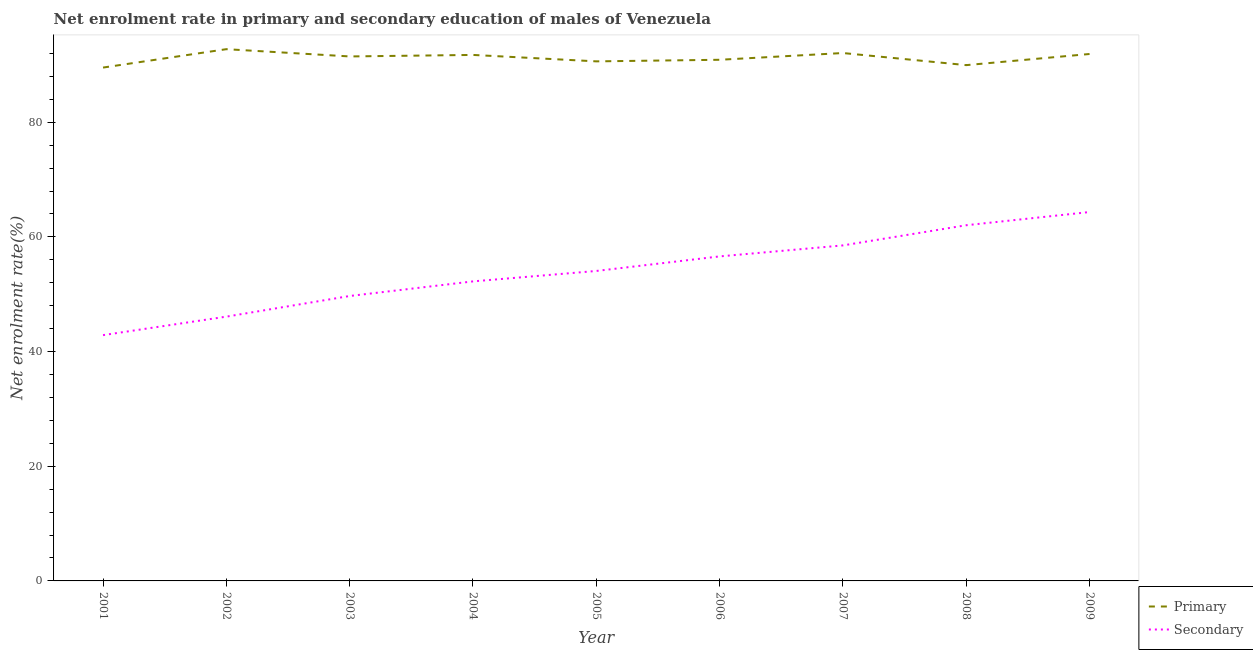How many different coloured lines are there?
Make the answer very short. 2. Is the number of lines equal to the number of legend labels?
Provide a succinct answer. Yes. What is the enrollment rate in primary education in 2006?
Your answer should be very brief. 90.89. Across all years, what is the maximum enrollment rate in primary education?
Offer a very short reply. 92.74. Across all years, what is the minimum enrollment rate in secondary education?
Ensure brevity in your answer.  42.87. In which year was the enrollment rate in secondary education minimum?
Make the answer very short. 2001. What is the total enrollment rate in secondary education in the graph?
Give a very brief answer. 486.46. What is the difference between the enrollment rate in secondary education in 2001 and that in 2002?
Offer a terse response. -3.22. What is the difference between the enrollment rate in primary education in 2007 and the enrollment rate in secondary education in 2003?
Offer a very short reply. 42.38. What is the average enrollment rate in primary education per year?
Ensure brevity in your answer.  91.22. In the year 2009, what is the difference between the enrollment rate in primary education and enrollment rate in secondary education?
Keep it short and to the point. 27.56. What is the ratio of the enrollment rate in primary education in 2004 to that in 2005?
Your answer should be very brief. 1.01. Is the enrollment rate in primary education in 2004 less than that in 2009?
Keep it short and to the point. Yes. What is the difference between the highest and the second highest enrollment rate in primary education?
Your response must be concise. 0.67. What is the difference between the highest and the lowest enrollment rate in secondary education?
Your response must be concise. 21.47. Is the sum of the enrollment rate in primary education in 2001 and 2006 greater than the maximum enrollment rate in secondary education across all years?
Provide a short and direct response. Yes. Is the enrollment rate in secondary education strictly greater than the enrollment rate in primary education over the years?
Ensure brevity in your answer.  No. How many years are there in the graph?
Ensure brevity in your answer.  9. Are the values on the major ticks of Y-axis written in scientific E-notation?
Offer a terse response. No. Does the graph contain any zero values?
Give a very brief answer. No. How many legend labels are there?
Make the answer very short. 2. What is the title of the graph?
Offer a very short reply. Net enrolment rate in primary and secondary education of males of Venezuela. Does "Automatic Teller Machines" appear as one of the legend labels in the graph?
Your response must be concise. No. What is the label or title of the Y-axis?
Offer a terse response. Net enrolment rate(%). What is the Net enrolment rate(%) in Primary in 2001?
Keep it short and to the point. 89.54. What is the Net enrolment rate(%) of Secondary in 2001?
Offer a terse response. 42.87. What is the Net enrolment rate(%) in Primary in 2002?
Provide a succinct answer. 92.74. What is the Net enrolment rate(%) in Secondary in 2002?
Give a very brief answer. 46.09. What is the Net enrolment rate(%) of Primary in 2003?
Offer a very short reply. 91.48. What is the Net enrolment rate(%) of Secondary in 2003?
Give a very brief answer. 49.69. What is the Net enrolment rate(%) of Primary in 2004?
Offer a very short reply. 91.74. What is the Net enrolment rate(%) of Secondary in 2004?
Ensure brevity in your answer.  52.24. What is the Net enrolment rate(%) of Primary in 2005?
Provide a short and direct response. 90.62. What is the Net enrolment rate(%) of Secondary in 2005?
Give a very brief answer. 54.06. What is the Net enrolment rate(%) in Primary in 2006?
Give a very brief answer. 90.89. What is the Net enrolment rate(%) of Secondary in 2006?
Keep it short and to the point. 56.6. What is the Net enrolment rate(%) of Primary in 2007?
Your response must be concise. 92.07. What is the Net enrolment rate(%) of Secondary in 2007?
Keep it short and to the point. 58.52. What is the Net enrolment rate(%) of Primary in 2008?
Keep it short and to the point. 89.96. What is the Net enrolment rate(%) of Secondary in 2008?
Give a very brief answer. 62.04. What is the Net enrolment rate(%) in Primary in 2009?
Your answer should be very brief. 91.9. What is the Net enrolment rate(%) in Secondary in 2009?
Your answer should be compact. 64.34. Across all years, what is the maximum Net enrolment rate(%) of Primary?
Your response must be concise. 92.74. Across all years, what is the maximum Net enrolment rate(%) in Secondary?
Offer a very short reply. 64.34. Across all years, what is the minimum Net enrolment rate(%) of Primary?
Offer a very short reply. 89.54. Across all years, what is the minimum Net enrolment rate(%) in Secondary?
Offer a terse response. 42.87. What is the total Net enrolment rate(%) in Primary in the graph?
Your response must be concise. 820.95. What is the total Net enrolment rate(%) in Secondary in the graph?
Keep it short and to the point. 486.46. What is the difference between the Net enrolment rate(%) of Primary in 2001 and that in 2002?
Your response must be concise. -3.21. What is the difference between the Net enrolment rate(%) of Secondary in 2001 and that in 2002?
Your response must be concise. -3.23. What is the difference between the Net enrolment rate(%) of Primary in 2001 and that in 2003?
Keep it short and to the point. -1.94. What is the difference between the Net enrolment rate(%) in Secondary in 2001 and that in 2003?
Your answer should be very brief. -6.82. What is the difference between the Net enrolment rate(%) in Primary in 2001 and that in 2004?
Offer a very short reply. -2.2. What is the difference between the Net enrolment rate(%) in Secondary in 2001 and that in 2004?
Give a very brief answer. -9.37. What is the difference between the Net enrolment rate(%) of Primary in 2001 and that in 2005?
Provide a succinct answer. -1.08. What is the difference between the Net enrolment rate(%) in Secondary in 2001 and that in 2005?
Your answer should be very brief. -11.19. What is the difference between the Net enrolment rate(%) of Primary in 2001 and that in 2006?
Your answer should be very brief. -1.36. What is the difference between the Net enrolment rate(%) in Secondary in 2001 and that in 2006?
Provide a succinct answer. -13.73. What is the difference between the Net enrolment rate(%) of Primary in 2001 and that in 2007?
Give a very brief answer. -2.54. What is the difference between the Net enrolment rate(%) in Secondary in 2001 and that in 2007?
Make the answer very short. -15.65. What is the difference between the Net enrolment rate(%) of Primary in 2001 and that in 2008?
Your answer should be compact. -0.42. What is the difference between the Net enrolment rate(%) in Secondary in 2001 and that in 2008?
Offer a terse response. -19.17. What is the difference between the Net enrolment rate(%) of Primary in 2001 and that in 2009?
Offer a very short reply. -2.37. What is the difference between the Net enrolment rate(%) of Secondary in 2001 and that in 2009?
Ensure brevity in your answer.  -21.47. What is the difference between the Net enrolment rate(%) of Primary in 2002 and that in 2003?
Ensure brevity in your answer.  1.27. What is the difference between the Net enrolment rate(%) of Secondary in 2002 and that in 2003?
Make the answer very short. -3.6. What is the difference between the Net enrolment rate(%) of Secondary in 2002 and that in 2004?
Provide a short and direct response. -6.15. What is the difference between the Net enrolment rate(%) in Primary in 2002 and that in 2005?
Your answer should be very brief. 2.13. What is the difference between the Net enrolment rate(%) of Secondary in 2002 and that in 2005?
Provide a short and direct response. -7.97. What is the difference between the Net enrolment rate(%) of Primary in 2002 and that in 2006?
Provide a short and direct response. 1.85. What is the difference between the Net enrolment rate(%) of Secondary in 2002 and that in 2006?
Your response must be concise. -10.51. What is the difference between the Net enrolment rate(%) of Primary in 2002 and that in 2007?
Give a very brief answer. 0.67. What is the difference between the Net enrolment rate(%) in Secondary in 2002 and that in 2007?
Offer a terse response. -12.42. What is the difference between the Net enrolment rate(%) in Primary in 2002 and that in 2008?
Your answer should be very brief. 2.78. What is the difference between the Net enrolment rate(%) in Secondary in 2002 and that in 2008?
Keep it short and to the point. -15.94. What is the difference between the Net enrolment rate(%) of Primary in 2002 and that in 2009?
Ensure brevity in your answer.  0.84. What is the difference between the Net enrolment rate(%) in Secondary in 2002 and that in 2009?
Offer a very short reply. -18.24. What is the difference between the Net enrolment rate(%) in Primary in 2003 and that in 2004?
Offer a terse response. -0.26. What is the difference between the Net enrolment rate(%) in Secondary in 2003 and that in 2004?
Offer a terse response. -2.55. What is the difference between the Net enrolment rate(%) in Primary in 2003 and that in 2005?
Make the answer very short. 0.86. What is the difference between the Net enrolment rate(%) of Secondary in 2003 and that in 2005?
Your answer should be compact. -4.37. What is the difference between the Net enrolment rate(%) in Primary in 2003 and that in 2006?
Keep it short and to the point. 0.58. What is the difference between the Net enrolment rate(%) of Secondary in 2003 and that in 2006?
Keep it short and to the point. -6.91. What is the difference between the Net enrolment rate(%) of Primary in 2003 and that in 2007?
Provide a succinct answer. -0.6. What is the difference between the Net enrolment rate(%) of Secondary in 2003 and that in 2007?
Your response must be concise. -8.82. What is the difference between the Net enrolment rate(%) in Primary in 2003 and that in 2008?
Your answer should be very brief. 1.52. What is the difference between the Net enrolment rate(%) of Secondary in 2003 and that in 2008?
Offer a terse response. -12.34. What is the difference between the Net enrolment rate(%) in Primary in 2003 and that in 2009?
Make the answer very short. -0.43. What is the difference between the Net enrolment rate(%) in Secondary in 2003 and that in 2009?
Offer a very short reply. -14.64. What is the difference between the Net enrolment rate(%) in Primary in 2004 and that in 2005?
Your answer should be compact. 1.12. What is the difference between the Net enrolment rate(%) in Secondary in 2004 and that in 2005?
Your answer should be compact. -1.82. What is the difference between the Net enrolment rate(%) of Primary in 2004 and that in 2006?
Ensure brevity in your answer.  0.85. What is the difference between the Net enrolment rate(%) in Secondary in 2004 and that in 2006?
Keep it short and to the point. -4.36. What is the difference between the Net enrolment rate(%) of Primary in 2004 and that in 2007?
Offer a terse response. -0.33. What is the difference between the Net enrolment rate(%) of Secondary in 2004 and that in 2007?
Your response must be concise. -6.28. What is the difference between the Net enrolment rate(%) in Primary in 2004 and that in 2008?
Give a very brief answer. 1.78. What is the difference between the Net enrolment rate(%) in Secondary in 2004 and that in 2008?
Offer a terse response. -9.79. What is the difference between the Net enrolment rate(%) in Primary in 2004 and that in 2009?
Ensure brevity in your answer.  -0.16. What is the difference between the Net enrolment rate(%) in Secondary in 2004 and that in 2009?
Give a very brief answer. -12.1. What is the difference between the Net enrolment rate(%) in Primary in 2005 and that in 2006?
Ensure brevity in your answer.  -0.28. What is the difference between the Net enrolment rate(%) in Secondary in 2005 and that in 2006?
Your response must be concise. -2.54. What is the difference between the Net enrolment rate(%) of Primary in 2005 and that in 2007?
Ensure brevity in your answer.  -1.45. What is the difference between the Net enrolment rate(%) of Secondary in 2005 and that in 2007?
Give a very brief answer. -4.46. What is the difference between the Net enrolment rate(%) in Primary in 2005 and that in 2008?
Offer a very short reply. 0.66. What is the difference between the Net enrolment rate(%) in Secondary in 2005 and that in 2008?
Offer a terse response. -7.98. What is the difference between the Net enrolment rate(%) of Primary in 2005 and that in 2009?
Offer a terse response. -1.28. What is the difference between the Net enrolment rate(%) of Secondary in 2005 and that in 2009?
Provide a succinct answer. -10.28. What is the difference between the Net enrolment rate(%) of Primary in 2006 and that in 2007?
Provide a succinct answer. -1.18. What is the difference between the Net enrolment rate(%) in Secondary in 2006 and that in 2007?
Offer a terse response. -1.92. What is the difference between the Net enrolment rate(%) of Primary in 2006 and that in 2008?
Your answer should be very brief. 0.93. What is the difference between the Net enrolment rate(%) of Secondary in 2006 and that in 2008?
Keep it short and to the point. -5.44. What is the difference between the Net enrolment rate(%) of Primary in 2006 and that in 2009?
Make the answer very short. -1.01. What is the difference between the Net enrolment rate(%) in Secondary in 2006 and that in 2009?
Your response must be concise. -7.74. What is the difference between the Net enrolment rate(%) in Primary in 2007 and that in 2008?
Make the answer very short. 2.11. What is the difference between the Net enrolment rate(%) of Secondary in 2007 and that in 2008?
Keep it short and to the point. -3.52. What is the difference between the Net enrolment rate(%) in Primary in 2007 and that in 2009?
Give a very brief answer. 0.17. What is the difference between the Net enrolment rate(%) of Secondary in 2007 and that in 2009?
Offer a very short reply. -5.82. What is the difference between the Net enrolment rate(%) of Primary in 2008 and that in 2009?
Keep it short and to the point. -1.94. What is the difference between the Net enrolment rate(%) in Secondary in 2008 and that in 2009?
Make the answer very short. -2.3. What is the difference between the Net enrolment rate(%) of Primary in 2001 and the Net enrolment rate(%) of Secondary in 2002?
Your answer should be compact. 43.44. What is the difference between the Net enrolment rate(%) of Primary in 2001 and the Net enrolment rate(%) of Secondary in 2003?
Ensure brevity in your answer.  39.84. What is the difference between the Net enrolment rate(%) of Primary in 2001 and the Net enrolment rate(%) of Secondary in 2004?
Keep it short and to the point. 37.29. What is the difference between the Net enrolment rate(%) of Primary in 2001 and the Net enrolment rate(%) of Secondary in 2005?
Your answer should be compact. 35.47. What is the difference between the Net enrolment rate(%) in Primary in 2001 and the Net enrolment rate(%) in Secondary in 2006?
Provide a short and direct response. 32.94. What is the difference between the Net enrolment rate(%) in Primary in 2001 and the Net enrolment rate(%) in Secondary in 2007?
Your answer should be compact. 31.02. What is the difference between the Net enrolment rate(%) in Primary in 2001 and the Net enrolment rate(%) in Secondary in 2008?
Make the answer very short. 27.5. What is the difference between the Net enrolment rate(%) of Primary in 2001 and the Net enrolment rate(%) of Secondary in 2009?
Offer a very short reply. 25.2. What is the difference between the Net enrolment rate(%) of Primary in 2002 and the Net enrolment rate(%) of Secondary in 2003?
Your response must be concise. 43.05. What is the difference between the Net enrolment rate(%) of Primary in 2002 and the Net enrolment rate(%) of Secondary in 2004?
Offer a very short reply. 40.5. What is the difference between the Net enrolment rate(%) of Primary in 2002 and the Net enrolment rate(%) of Secondary in 2005?
Ensure brevity in your answer.  38.68. What is the difference between the Net enrolment rate(%) of Primary in 2002 and the Net enrolment rate(%) of Secondary in 2006?
Offer a very short reply. 36.14. What is the difference between the Net enrolment rate(%) in Primary in 2002 and the Net enrolment rate(%) in Secondary in 2007?
Ensure brevity in your answer.  34.23. What is the difference between the Net enrolment rate(%) of Primary in 2002 and the Net enrolment rate(%) of Secondary in 2008?
Ensure brevity in your answer.  30.71. What is the difference between the Net enrolment rate(%) in Primary in 2002 and the Net enrolment rate(%) in Secondary in 2009?
Keep it short and to the point. 28.41. What is the difference between the Net enrolment rate(%) in Primary in 2003 and the Net enrolment rate(%) in Secondary in 2004?
Your answer should be very brief. 39.23. What is the difference between the Net enrolment rate(%) in Primary in 2003 and the Net enrolment rate(%) in Secondary in 2005?
Provide a short and direct response. 37.41. What is the difference between the Net enrolment rate(%) of Primary in 2003 and the Net enrolment rate(%) of Secondary in 2006?
Your response must be concise. 34.88. What is the difference between the Net enrolment rate(%) of Primary in 2003 and the Net enrolment rate(%) of Secondary in 2007?
Keep it short and to the point. 32.96. What is the difference between the Net enrolment rate(%) in Primary in 2003 and the Net enrolment rate(%) in Secondary in 2008?
Provide a short and direct response. 29.44. What is the difference between the Net enrolment rate(%) in Primary in 2003 and the Net enrolment rate(%) in Secondary in 2009?
Offer a very short reply. 27.14. What is the difference between the Net enrolment rate(%) of Primary in 2004 and the Net enrolment rate(%) of Secondary in 2005?
Make the answer very short. 37.68. What is the difference between the Net enrolment rate(%) in Primary in 2004 and the Net enrolment rate(%) in Secondary in 2006?
Give a very brief answer. 35.14. What is the difference between the Net enrolment rate(%) in Primary in 2004 and the Net enrolment rate(%) in Secondary in 2007?
Ensure brevity in your answer.  33.22. What is the difference between the Net enrolment rate(%) of Primary in 2004 and the Net enrolment rate(%) of Secondary in 2008?
Your response must be concise. 29.7. What is the difference between the Net enrolment rate(%) of Primary in 2004 and the Net enrolment rate(%) of Secondary in 2009?
Provide a succinct answer. 27.4. What is the difference between the Net enrolment rate(%) in Primary in 2005 and the Net enrolment rate(%) in Secondary in 2006?
Offer a terse response. 34.02. What is the difference between the Net enrolment rate(%) of Primary in 2005 and the Net enrolment rate(%) of Secondary in 2007?
Make the answer very short. 32.1. What is the difference between the Net enrolment rate(%) of Primary in 2005 and the Net enrolment rate(%) of Secondary in 2008?
Your answer should be very brief. 28.58. What is the difference between the Net enrolment rate(%) of Primary in 2005 and the Net enrolment rate(%) of Secondary in 2009?
Offer a terse response. 26.28. What is the difference between the Net enrolment rate(%) in Primary in 2006 and the Net enrolment rate(%) in Secondary in 2007?
Make the answer very short. 32.38. What is the difference between the Net enrolment rate(%) in Primary in 2006 and the Net enrolment rate(%) in Secondary in 2008?
Offer a terse response. 28.86. What is the difference between the Net enrolment rate(%) of Primary in 2006 and the Net enrolment rate(%) of Secondary in 2009?
Offer a terse response. 26.56. What is the difference between the Net enrolment rate(%) in Primary in 2007 and the Net enrolment rate(%) in Secondary in 2008?
Your answer should be compact. 30.03. What is the difference between the Net enrolment rate(%) in Primary in 2007 and the Net enrolment rate(%) in Secondary in 2009?
Your answer should be compact. 27.73. What is the difference between the Net enrolment rate(%) of Primary in 2008 and the Net enrolment rate(%) of Secondary in 2009?
Your answer should be compact. 25.62. What is the average Net enrolment rate(%) of Primary per year?
Give a very brief answer. 91.22. What is the average Net enrolment rate(%) of Secondary per year?
Give a very brief answer. 54.05. In the year 2001, what is the difference between the Net enrolment rate(%) of Primary and Net enrolment rate(%) of Secondary?
Make the answer very short. 46.67. In the year 2002, what is the difference between the Net enrolment rate(%) of Primary and Net enrolment rate(%) of Secondary?
Offer a very short reply. 46.65. In the year 2003, what is the difference between the Net enrolment rate(%) of Primary and Net enrolment rate(%) of Secondary?
Your answer should be very brief. 41.78. In the year 2004, what is the difference between the Net enrolment rate(%) in Primary and Net enrolment rate(%) in Secondary?
Provide a succinct answer. 39.5. In the year 2005, what is the difference between the Net enrolment rate(%) of Primary and Net enrolment rate(%) of Secondary?
Provide a succinct answer. 36.56. In the year 2006, what is the difference between the Net enrolment rate(%) of Primary and Net enrolment rate(%) of Secondary?
Ensure brevity in your answer.  34.29. In the year 2007, what is the difference between the Net enrolment rate(%) of Primary and Net enrolment rate(%) of Secondary?
Ensure brevity in your answer.  33.55. In the year 2008, what is the difference between the Net enrolment rate(%) in Primary and Net enrolment rate(%) in Secondary?
Your answer should be compact. 27.92. In the year 2009, what is the difference between the Net enrolment rate(%) in Primary and Net enrolment rate(%) in Secondary?
Give a very brief answer. 27.56. What is the ratio of the Net enrolment rate(%) in Primary in 2001 to that in 2002?
Provide a short and direct response. 0.97. What is the ratio of the Net enrolment rate(%) of Primary in 2001 to that in 2003?
Your answer should be very brief. 0.98. What is the ratio of the Net enrolment rate(%) in Secondary in 2001 to that in 2003?
Provide a short and direct response. 0.86. What is the ratio of the Net enrolment rate(%) in Primary in 2001 to that in 2004?
Provide a succinct answer. 0.98. What is the ratio of the Net enrolment rate(%) in Secondary in 2001 to that in 2004?
Your answer should be compact. 0.82. What is the ratio of the Net enrolment rate(%) of Secondary in 2001 to that in 2005?
Your answer should be compact. 0.79. What is the ratio of the Net enrolment rate(%) in Primary in 2001 to that in 2006?
Offer a very short reply. 0.99. What is the ratio of the Net enrolment rate(%) in Secondary in 2001 to that in 2006?
Your answer should be very brief. 0.76. What is the ratio of the Net enrolment rate(%) of Primary in 2001 to that in 2007?
Give a very brief answer. 0.97. What is the ratio of the Net enrolment rate(%) of Secondary in 2001 to that in 2007?
Give a very brief answer. 0.73. What is the ratio of the Net enrolment rate(%) of Secondary in 2001 to that in 2008?
Provide a short and direct response. 0.69. What is the ratio of the Net enrolment rate(%) of Primary in 2001 to that in 2009?
Give a very brief answer. 0.97. What is the ratio of the Net enrolment rate(%) of Secondary in 2001 to that in 2009?
Your response must be concise. 0.67. What is the ratio of the Net enrolment rate(%) of Primary in 2002 to that in 2003?
Your answer should be compact. 1.01. What is the ratio of the Net enrolment rate(%) in Secondary in 2002 to that in 2003?
Offer a very short reply. 0.93. What is the ratio of the Net enrolment rate(%) of Primary in 2002 to that in 2004?
Make the answer very short. 1.01. What is the ratio of the Net enrolment rate(%) of Secondary in 2002 to that in 2004?
Provide a short and direct response. 0.88. What is the ratio of the Net enrolment rate(%) in Primary in 2002 to that in 2005?
Offer a terse response. 1.02. What is the ratio of the Net enrolment rate(%) in Secondary in 2002 to that in 2005?
Provide a short and direct response. 0.85. What is the ratio of the Net enrolment rate(%) of Primary in 2002 to that in 2006?
Offer a terse response. 1.02. What is the ratio of the Net enrolment rate(%) of Secondary in 2002 to that in 2006?
Offer a terse response. 0.81. What is the ratio of the Net enrolment rate(%) in Primary in 2002 to that in 2007?
Your response must be concise. 1.01. What is the ratio of the Net enrolment rate(%) in Secondary in 2002 to that in 2007?
Keep it short and to the point. 0.79. What is the ratio of the Net enrolment rate(%) of Primary in 2002 to that in 2008?
Make the answer very short. 1.03. What is the ratio of the Net enrolment rate(%) in Secondary in 2002 to that in 2008?
Your answer should be very brief. 0.74. What is the ratio of the Net enrolment rate(%) in Primary in 2002 to that in 2009?
Provide a short and direct response. 1.01. What is the ratio of the Net enrolment rate(%) in Secondary in 2002 to that in 2009?
Provide a succinct answer. 0.72. What is the ratio of the Net enrolment rate(%) in Secondary in 2003 to that in 2004?
Give a very brief answer. 0.95. What is the ratio of the Net enrolment rate(%) of Primary in 2003 to that in 2005?
Your answer should be very brief. 1.01. What is the ratio of the Net enrolment rate(%) in Secondary in 2003 to that in 2005?
Your answer should be compact. 0.92. What is the ratio of the Net enrolment rate(%) in Primary in 2003 to that in 2006?
Your answer should be very brief. 1.01. What is the ratio of the Net enrolment rate(%) in Secondary in 2003 to that in 2006?
Your response must be concise. 0.88. What is the ratio of the Net enrolment rate(%) of Primary in 2003 to that in 2007?
Provide a short and direct response. 0.99. What is the ratio of the Net enrolment rate(%) in Secondary in 2003 to that in 2007?
Offer a very short reply. 0.85. What is the ratio of the Net enrolment rate(%) of Primary in 2003 to that in 2008?
Your response must be concise. 1.02. What is the ratio of the Net enrolment rate(%) in Secondary in 2003 to that in 2008?
Keep it short and to the point. 0.8. What is the ratio of the Net enrolment rate(%) in Secondary in 2003 to that in 2009?
Keep it short and to the point. 0.77. What is the ratio of the Net enrolment rate(%) of Primary in 2004 to that in 2005?
Give a very brief answer. 1.01. What is the ratio of the Net enrolment rate(%) of Secondary in 2004 to that in 2005?
Provide a succinct answer. 0.97. What is the ratio of the Net enrolment rate(%) of Primary in 2004 to that in 2006?
Your answer should be very brief. 1.01. What is the ratio of the Net enrolment rate(%) of Secondary in 2004 to that in 2006?
Give a very brief answer. 0.92. What is the ratio of the Net enrolment rate(%) in Primary in 2004 to that in 2007?
Give a very brief answer. 1. What is the ratio of the Net enrolment rate(%) of Secondary in 2004 to that in 2007?
Your answer should be very brief. 0.89. What is the ratio of the Net enrolment rate(%) in Primary in 2004 to that in 2008?
Give a very brief answer. 1.02. What is the ratio of the Net enrolment rate(%) in Secondary in 2004 to that in 2008?
Give a very brief answer. 0.84. What is the ratio of the Net enrolment rate(%) of Primary in 2004 to that in 2009?
Ensure brevity in your answer.  1. What is the ratio of the Net enrolment rate(%) of Secondary in 2004 to that in 2009?
Offer a very short reply. 0.81. What is the ratio of the Net enrolment rate(%) of Primary in 2005 to that in 2006?
Offer a very short reply. 1. What is the ratio of the Net enrolment rate(%) of Secondary in 2005 to that in 2006?
Your answer should be compact. 0.96. What is the ratio of the Net enrolment rate(%) in Primary in 2005 to that in 2007?
Make the answer very short. 0.98. What is the ratio of the Net enrolment rate(%) in Secondary in 2005 to that in 2007?
Your answer should be compact. 0.92. What is the ratio of the Net enrolment rate(%) in Primary in 2005 to that in 2008?
Ensure brevity in your answer.  1.01. What is the ratio of the Net enrolment rate(%) in Secondary in 2005 to that in 2008?
Your response must be concise. 0.87. What is the ratio of the Net enrolment rate(%) of Secondary in 2005 to that in 2009?
Give a very brief answer. 0.84. What is the ratio of the Net enrolment rate(%) in Primary in 2006 to that in 2007?
Your answer should be compact. 0.99. What is the ratio of the Net enrolment rate(%) in Secondary in 2006 to that in 2007?
Provide a succinct answer. 0.97. What is the ratio of the Net enrolment rate(%) in Primary in 2006 to that in 2008?
Keep it short and to the point. 1.01. What is the ratio of the Net enrolment rate(%) in Secondary in 2006 to that in 2008?
Offer a very short reply. 0.91. What is the ratio of the Net enrolment rate(%) in Secondary in 2006 to that in 2009?
Keep it short and to the point. 0.88. What is the ratio of the Net enrolment rate(%) of Primary in 2007 to that in 2008?
Offer a terse response. 1.02. What is the ratio of the Net enrolment rate(%) in Secondary in 2007 to that in 2008?
Provide a succinct answer. 0.94. What is the ratio of the Net enrolment rate(%) in Secondary in 2007 to that in 2009?
Offer a terse response. 0.91. What is the ratio of the Net enrolment rate(%) in Primary in 2008 to that in 2009?
Your response must be concise. 0.98. What is the ratio of the Net enrolment rate(%) in Secondary in 2008 to that in 2009?
Your answer should be very brief. 0.96. What is the difference between the highest and the second highest Net enrolment rate(%) of Primary?
Offer a terse response. 0.67. What is the difference between the highest and the second highest Net enrolment rate(%) in Secondary?
Make the answer very short. 2.3. What is the difference between the highest and the lowest Net enrolment rate(%) in Primary?
Your answer should be very brief. 3.21. What is the difference between the highest and the lowest Net enrolment rate(%) in Secondary?
Make the answer very short. 21.47. 